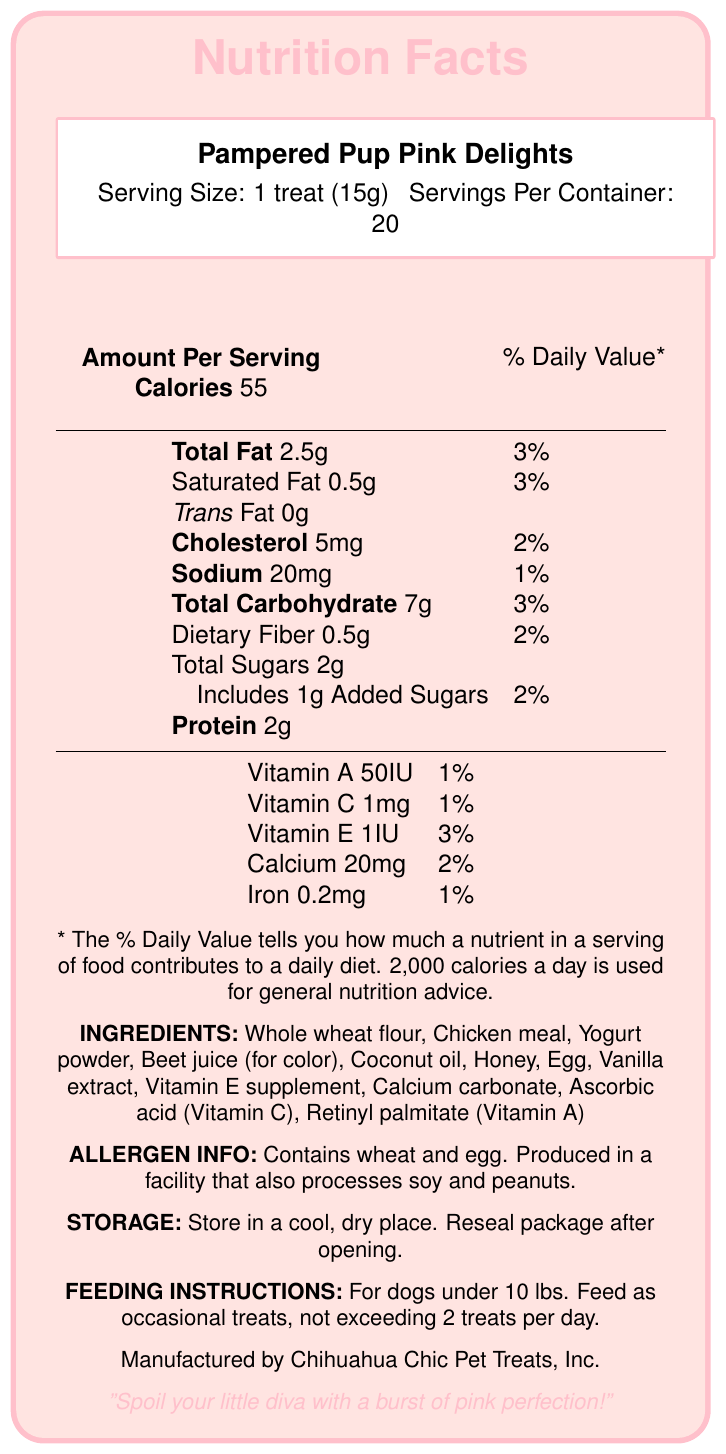What is the serving size for Pampered Pup Pink Delights? The serving size listed in the document is 1 treat, which weighs 15 grams.
Answer: 1 treat (15g) How many servings are there per container of Pampered Pup Pink Delights? The document states that there are 20 servings per container.
Answer: 20 How many calories are there in one treat? The amount of calories per serving, which is one treat, is listed as 55.
Answer: 55 How much total fat is in one treat and what is its % Daily Value? The total fat content per serving is 2.5 grams, which is 3% of the Daily Value.
Answer: 2.5g, 3% What are the feeding instructions for dogs under 10 lbs? The feeding instructions state that for dogs under 10 lbs, these treats should be given occasionally, with a maximum of 2 treats per day.
Answer: Feed as occasional treats, not exceeding 2 treats per day Which vitamins are included in Pampered Pup Pink Delights? A. Vitamin A and Vitamin C B. Vitamin A, Vitamin C, and Vitamin E C. Vitamin A and Vitamin E D. Vitamin C and Calcium The document lists Vitamin A, Vitamin C, and Vitamin E in the nutrient information.
Answer: B. Vitamin A, Vitamin C, and Vitamin E What is the main ingredient that gives color to the treat? A. Yogurt powder B. Honey C. Beet juice D. Vanilla extract The ingredient list states that beet juice is used for color.
Answer: C. Beet juice Does the treat contain trans fat? The document clearly lists "Trans Fat 0g," indicating there is no trans fat in the treat.
Answer: No Is there any cholesterol in these treats? The document indicates there is 5mg of cholesterol in each treat, which is 2% of the Daily Value.
Answer: Yes Identify potential allergens in these treats. The allergen info section states that the treats contain wheat and egg and are produced in a facility that also processes soy and peanuts.
Answer: Wheat and egg What storage conditions are recommended for Pampered Pup Pink Delights? The storage instructions advise keeping the treats in a cool, dry place and to reseal the package after opening.
Answer: Store in a cool, dry place. Reseal package after opening. True or False: These treats are made by Glamour Pup Treats, Inc. The manufacturer listed is Chihuahua Chic Pet Treats, Inc.
Answer: False Summarize the main idea of the document. The document provides a comprehensive overview of Pampered Pup Pink Delights, focusing on its nutritional content, ingredients, allergen warnings, storage recommendations, and feeding guidelines for small dogs, emphasizing its suitability for spoiling little dogs.
Answer: Pampered Pup Pink Delights is a gourmet dog treat designed for small dogs, with a focus on pink aesthetics and added vitamins. The packaging includes detailed nutritional information, ingredient list, allergen info, storage, and feeding instructions. What is the maximum number of treats you can feed a 15 lb dog daily? The feeding instructions only specify the limit for dogs under 10 lbs, not for dogs that weigh 15 lbs.
Answer: Cannot be determined 